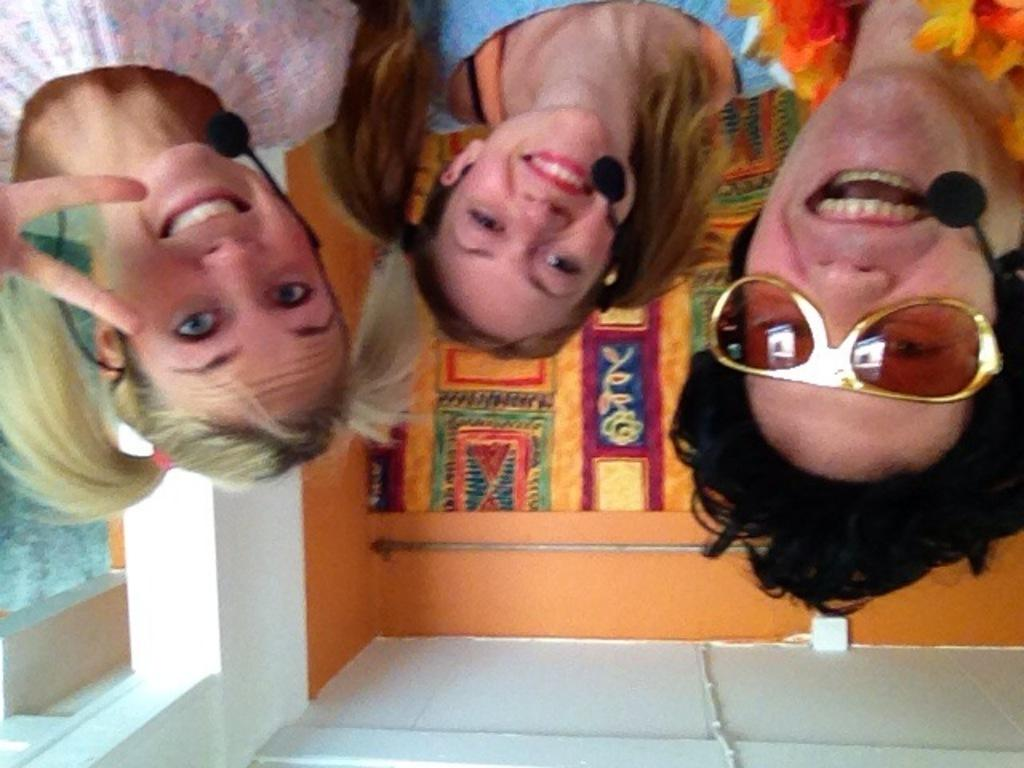How many people are present in the image? There are three persons in the image. What can be seen in the background of the image? There is a wall, a multi-color cloth, and trees in the background of the image. What is the color of the wall in the image? The wall is in orange color. What is the color of the trees in the image? The trees are in green color. What type of example is being used to teach division in the image? There is no example or teaching of division present in the image. Can you tell me how many apples are on the wall in the image? There are no apples present in the image; the wall is in orange color. 